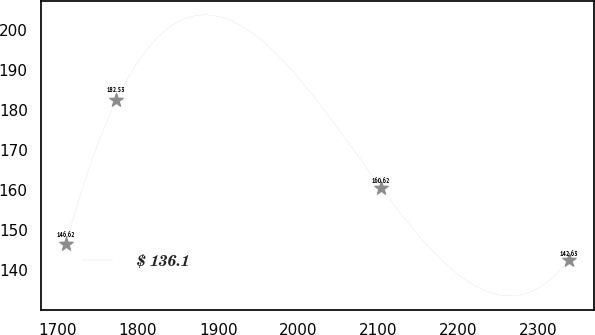Convert chart to OTSL. <chart><loc_0><loc_0><loc_500><loc_500><line_chart><ecel><fcel>$ 136.1<nl><fcel>1710.16<fcel>146.62<nl><fcel>1772.96<fcel>182.53<nl><fcel>2103.48<fcel>160.62<nl><fcel>2338.12<fcel>142.63<nl></chart> 